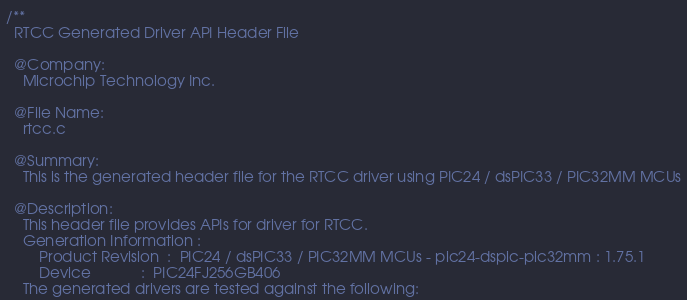<code> <loc_0><loc_0><loc_500><loc_500><_C_>
/**
  RTCC Generated Driver API Header File

  @Company:
    Microchip Technology Inc.

  @File Name:
    rtcc.c

  @Summary:
    This is the generated header file for the RTCC driver using PIC24 / dsPIC33 / PIC32MM MCUs

  @Description:
    This header file provides APIs for driver for RTCC.
    Generation Information :
        Product Revision  :  PIC24 / dsPIC33 / PIC32MM MCUs - pic24-dspic-pic32mm : 1.75.1
        Device            :  PIC24FJ256GB406
    The generated drivers are tested against the following:</code> 